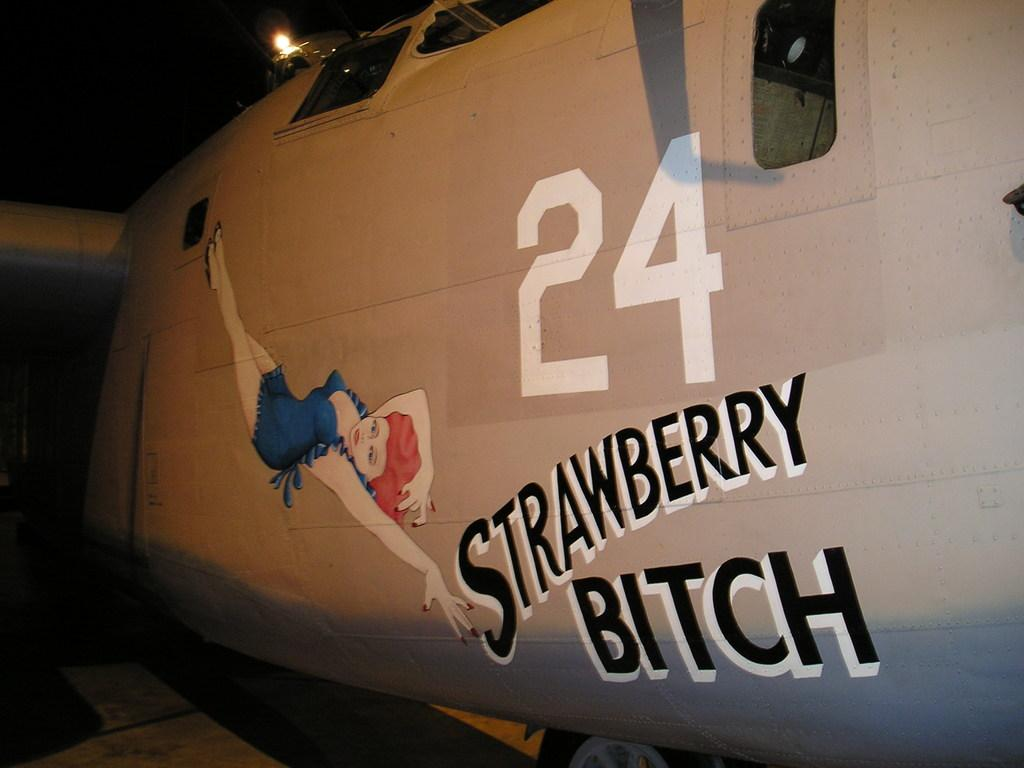<image>
Share a concise interpretation of the image provided. A side of a vehicle is painted with a female figure with a caption that reads "Strawberry bitch' 